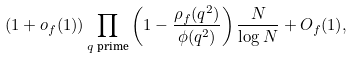<formula> <loc_0><loc_0><loc_500><loc_500>( 1 + o _ { f } ( 1 ) ) \prod _ { \text {$q$ prime} } \left ( 1 - \frac { \rho _ { f } ( q ^ { 2 } ) } { \phi ( q ^ { 2 } ) } \right ) \frac { N } { \log N } + O _ { f } ( 1 ) ,</formula> 